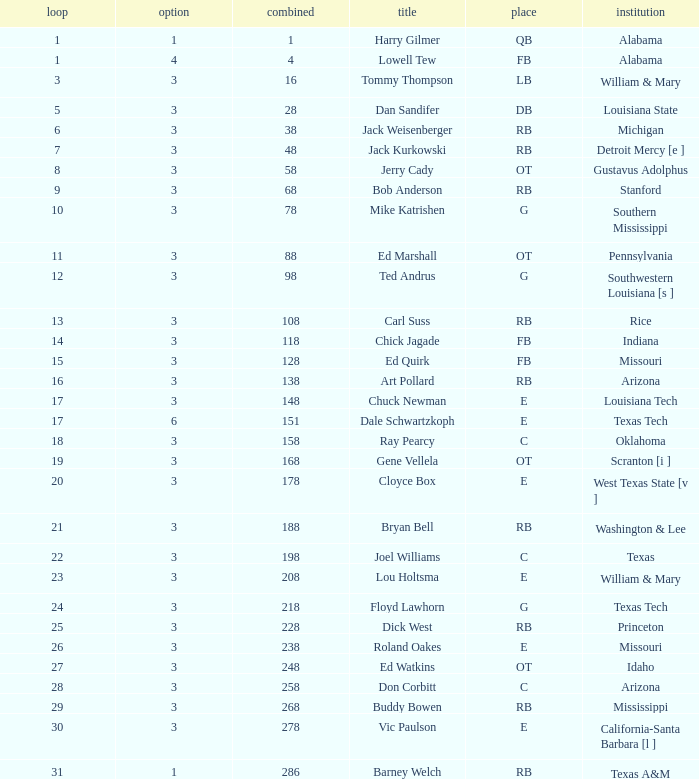What is stanford's average overall? 68.0. 